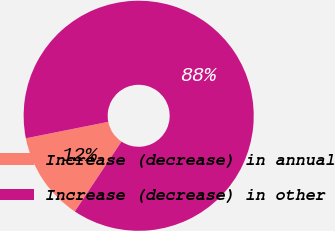Convert chart to OTSL. <chart><loc_0><loc_0><loc_500><loc_500><pie_chart><fcel>Increase (decrease) in annual<fcel>Increase (decrease) in other<nl><fcel>12.5%<fcel>87.5%<nl></chart> 